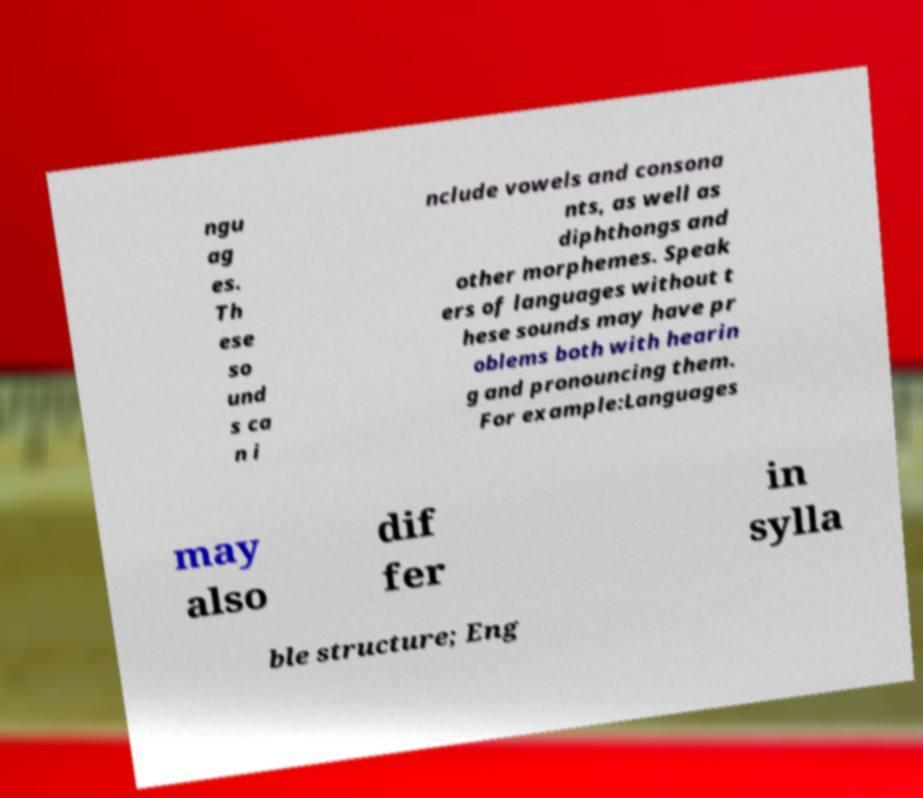Could you extract and type out the text from this image? ngu ag es. Th ese so und s ca n i nclude vowels and consona nts, as well as diphthongs and other morphemes. Speak ers of languages without t hese sounds may have pr oblems both with hearin g and pronouncing them. For example:Languages may also dif fer in sylla ble structure; Eng 